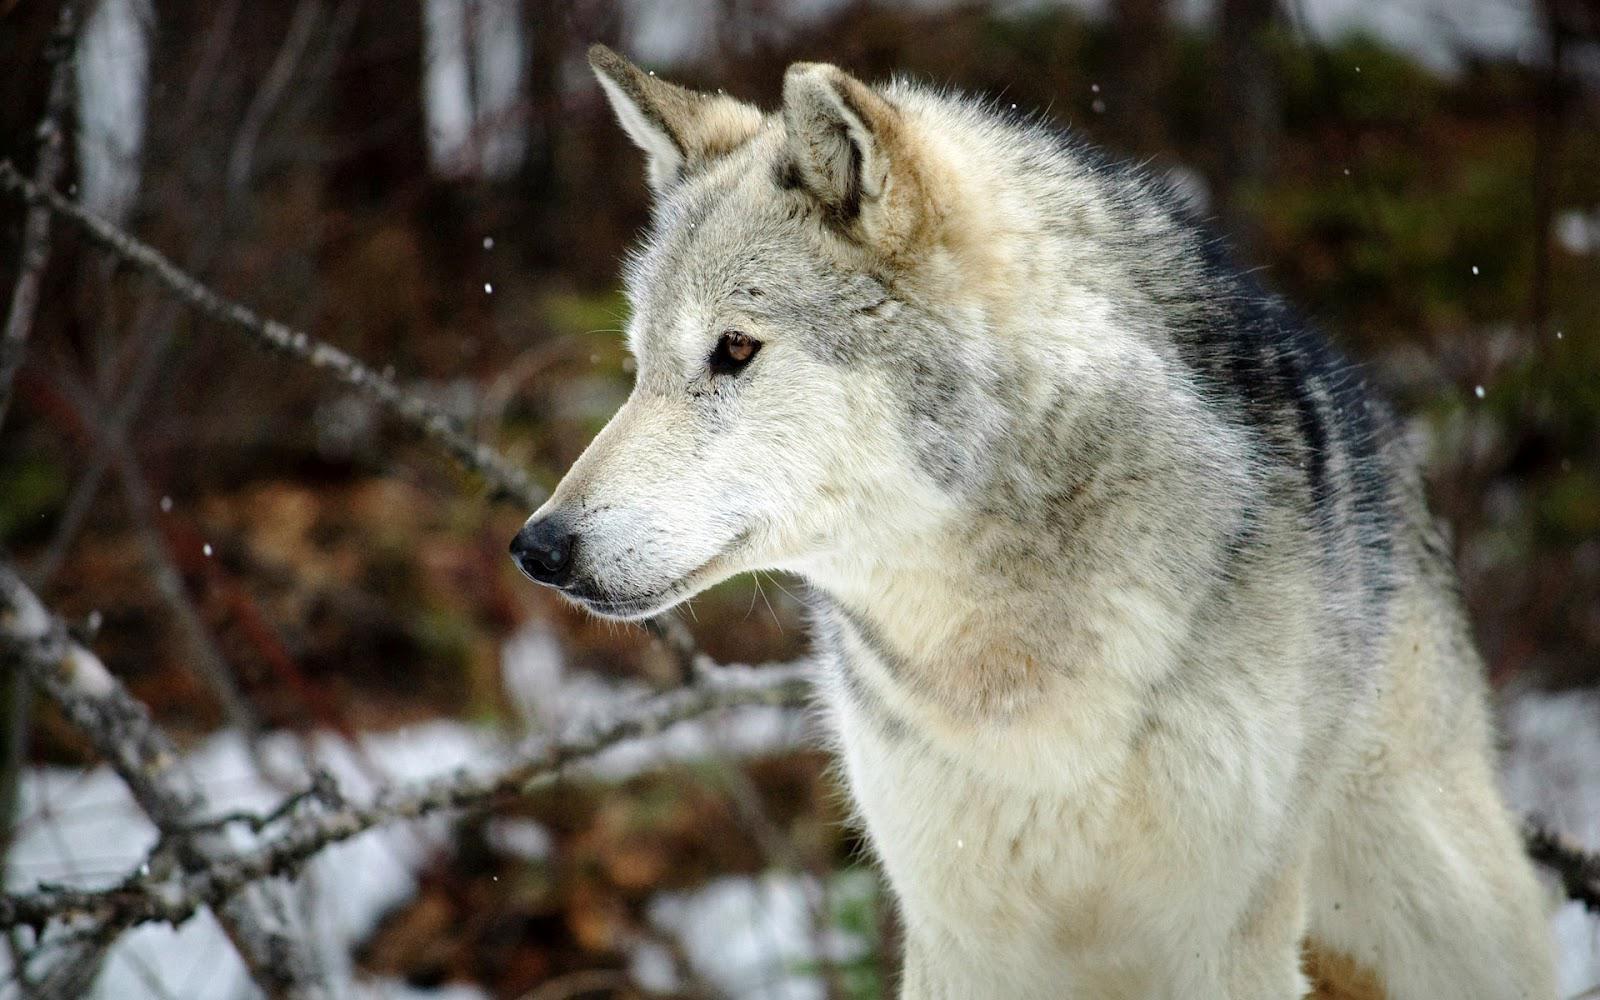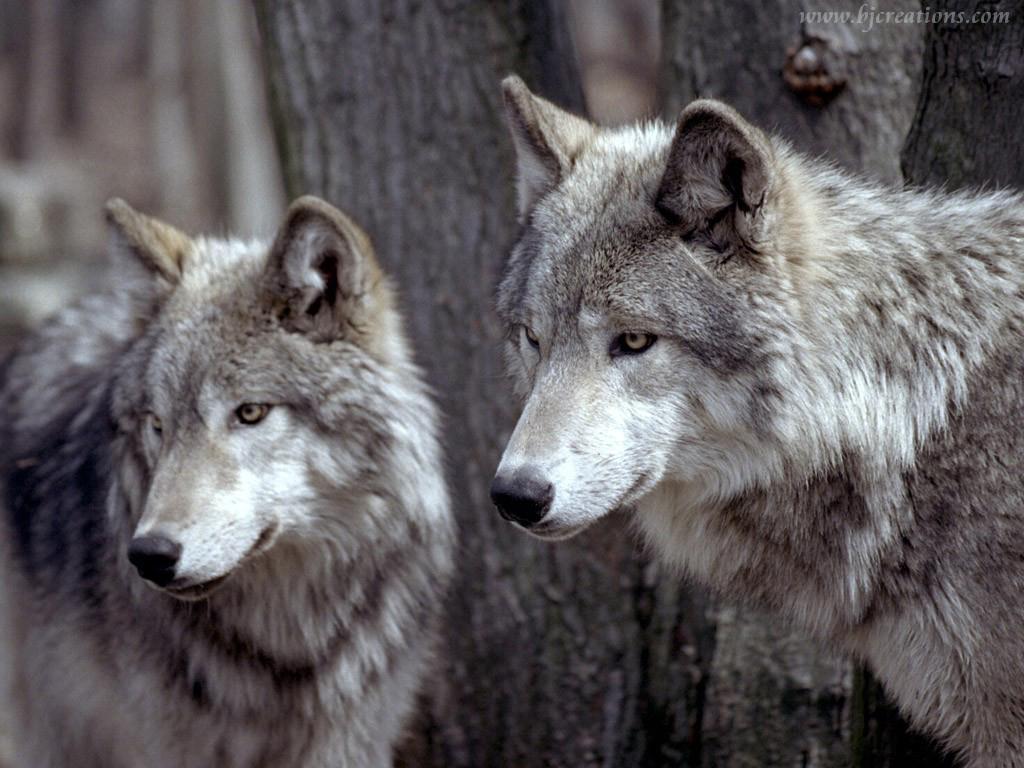The first image is the image on the left, the second image is the image on the right. Evaluate the accuracy of this statement regarding the images: "The wolf in the image on the left is in front of red foliage.". Is it true? Answer yes or no. No. The first image is the image on the left, the second image is the image on the right. For the images shown, is this caption "The wolf in the left image is looking left." true? Answer yes or no. Yes. 